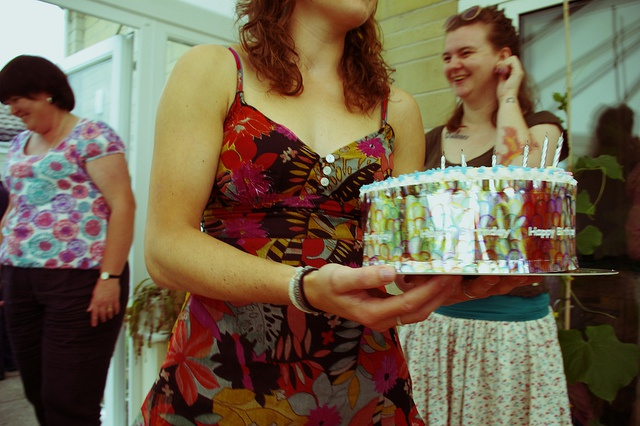Describe the objects in this image and their specific colors. I can see people in white, maroon, black, tan, and olive tones, people in white, black, darkgray, and brown tones, people in white, darkgray, tan, black, and maroon tones, cake in white, lightgray, maroon, lightblue, and olive tones, and potted plant in white, black, olive, and darkgreen tones in this image. 